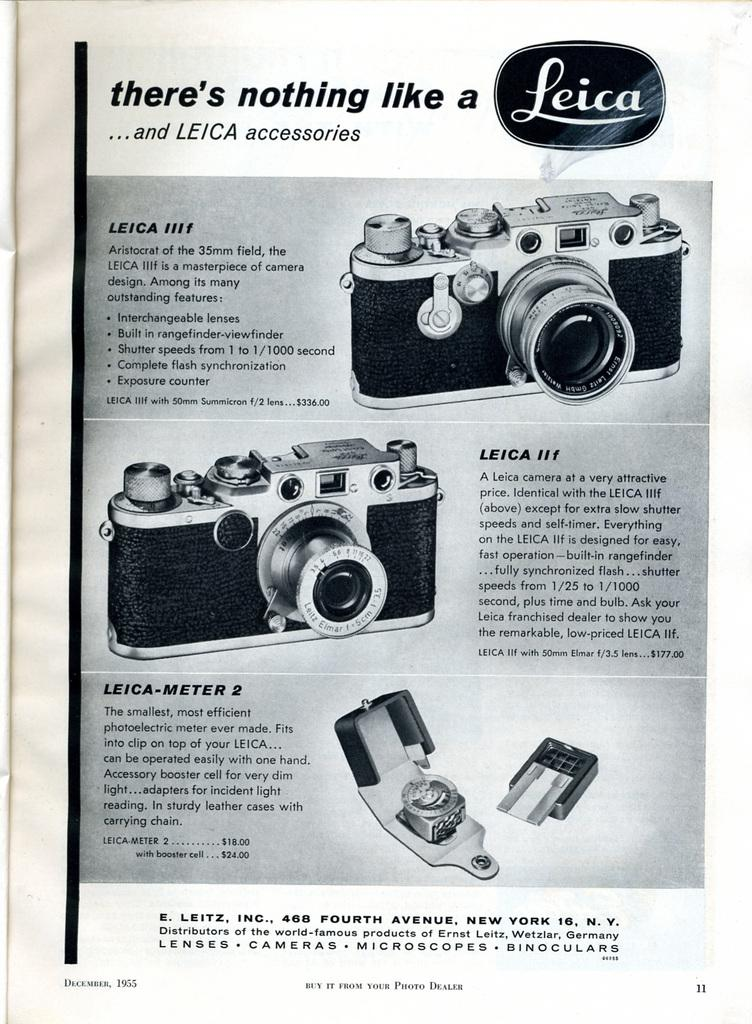What is the main subject of the image? The main subject of the image is photos of two cameras. Can you describe any other objects in the image? Yes, there is an object in the image. What is written on the paper in the image? There are words and numbers on a paper in the image. How do the giants interact with the cameras in the image? There are no giants present in the image, so they cannot interact with the cameras. What type of shock can be seen affecting the cameras in the image? There is no shock or any indication of damage to the cameras in the image. 